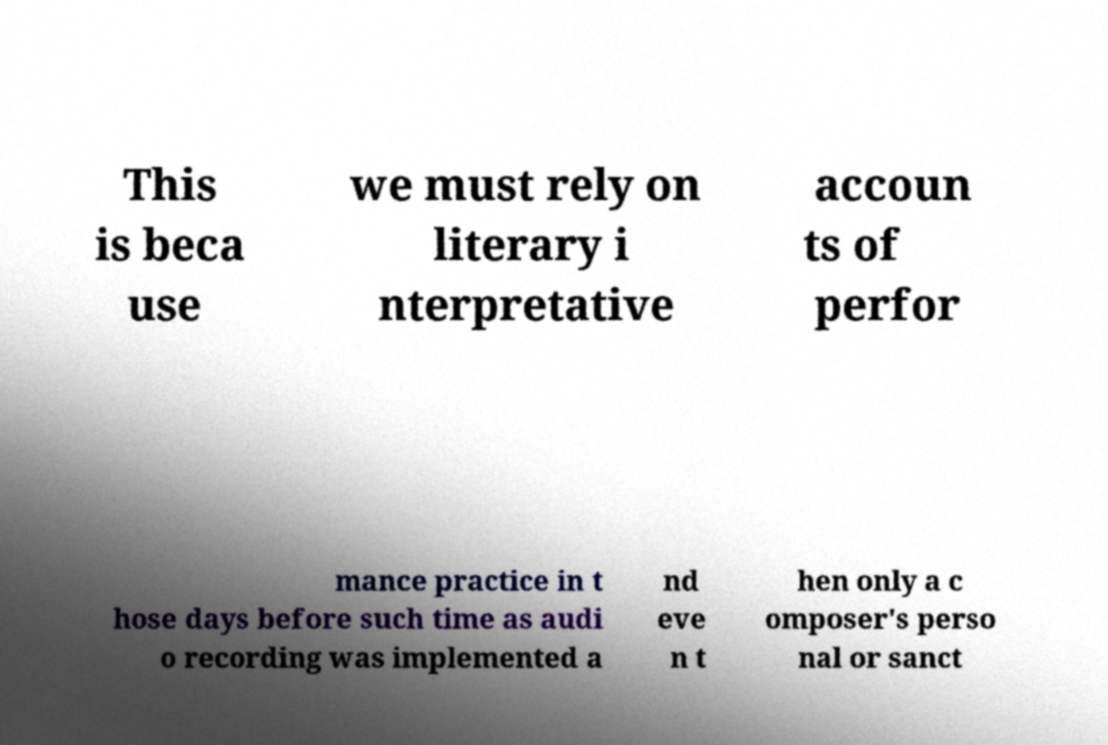There's text embedded in this image that I need extracted. Can you transcribe it verbatim? This is beca use we must rely on literary i nterpretative accoun ts of perfor mance practice in t hose days before such time as audi o recording was implemented a nd eve n t hen only a c omposer's perso nal or sanct 